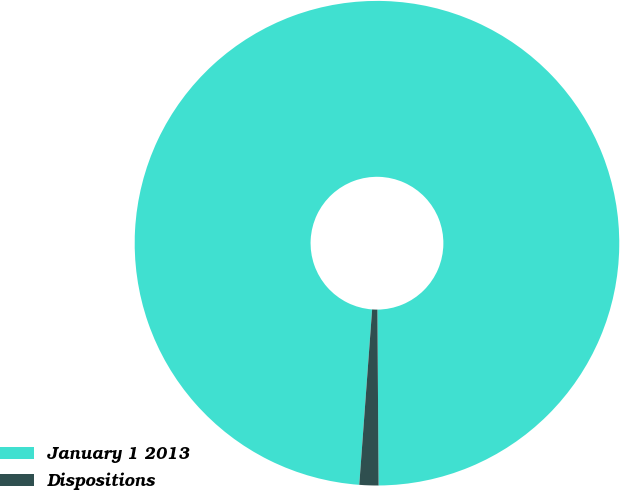Convert chart to OTSL. <chart><loc_0><loc_0><loc_500><loc_500><pie_chart><fcel>January 1 2013<fcel>Dispositions<nl><fcel>98.73%<fcel>1.27%<nl></chart> 